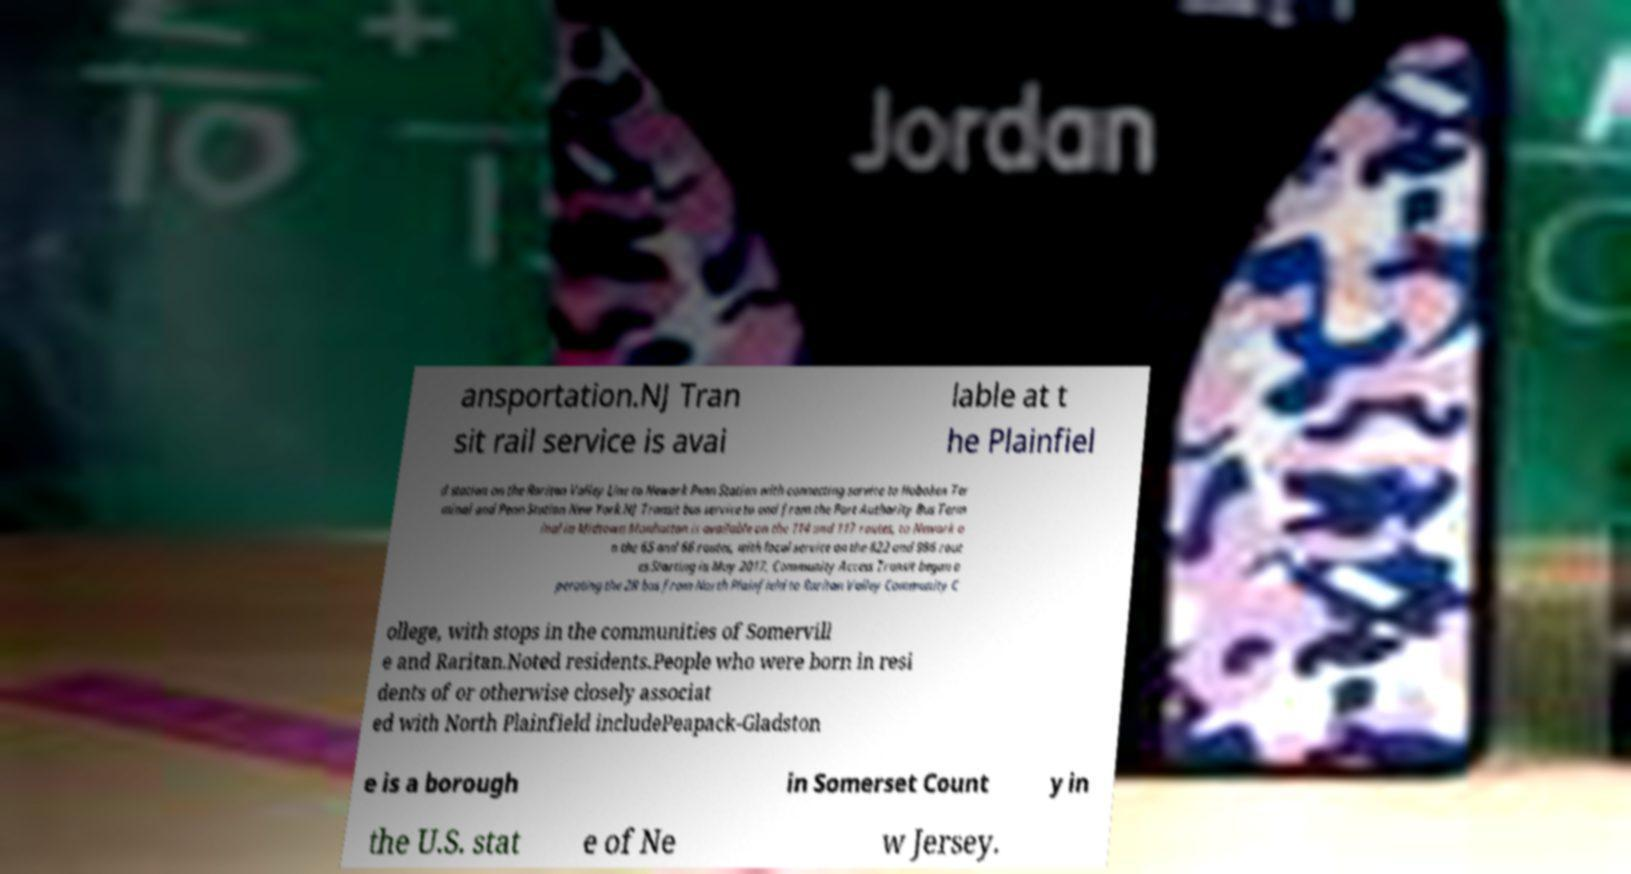Please identify and transcribe the text found in this image. ansportation.NJ Tran sit rail service is avai lable at t he Plainfiel d station on the Raritan Valley Line to Newark Penn Station with connecting service to Hoboken Ter minal and Penn Station New York.NJ Transit bus service to and from the Port Authority Bus Term inal in Midtown Manhattan is available on the 114 and 117 routes, to Newark o n the 65 and 66 routes, with local service on the 822 and 986 rout es.Starting in May 2017, Community Access Transit began o perating the 2R bus from North Plainfield to Raritan Valley Community C ollege, with stops in the communities of Somervill e and Raritan.Noted residents.People who were born in resi dents of or otherwise closely associat ed with North Plainfield includePeapack-Gladston e is a borough in Somerset Count y in the U.S. stat e of Ne w Jersey. 